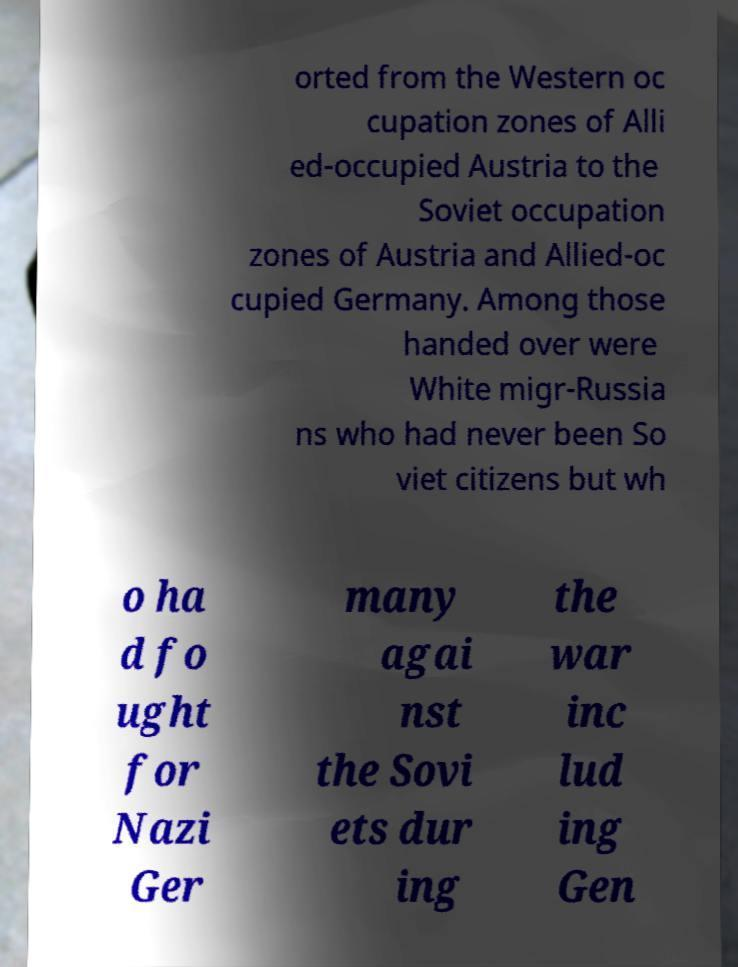For documentation purposes, I need the text within this image transcribed. Could you provide that? orted from the Western oc cupation zones of Alli ed-occupied Austria to the Soviet occupation zones of Austria and Allied-oc cupied Germany. Among those handed over were White migr-Russia ns who had never been So viet citizens but wh o ha d fo ught for Nazi Ger many agai nst the Sovi ets dur ing the war inc lud ing Gen 